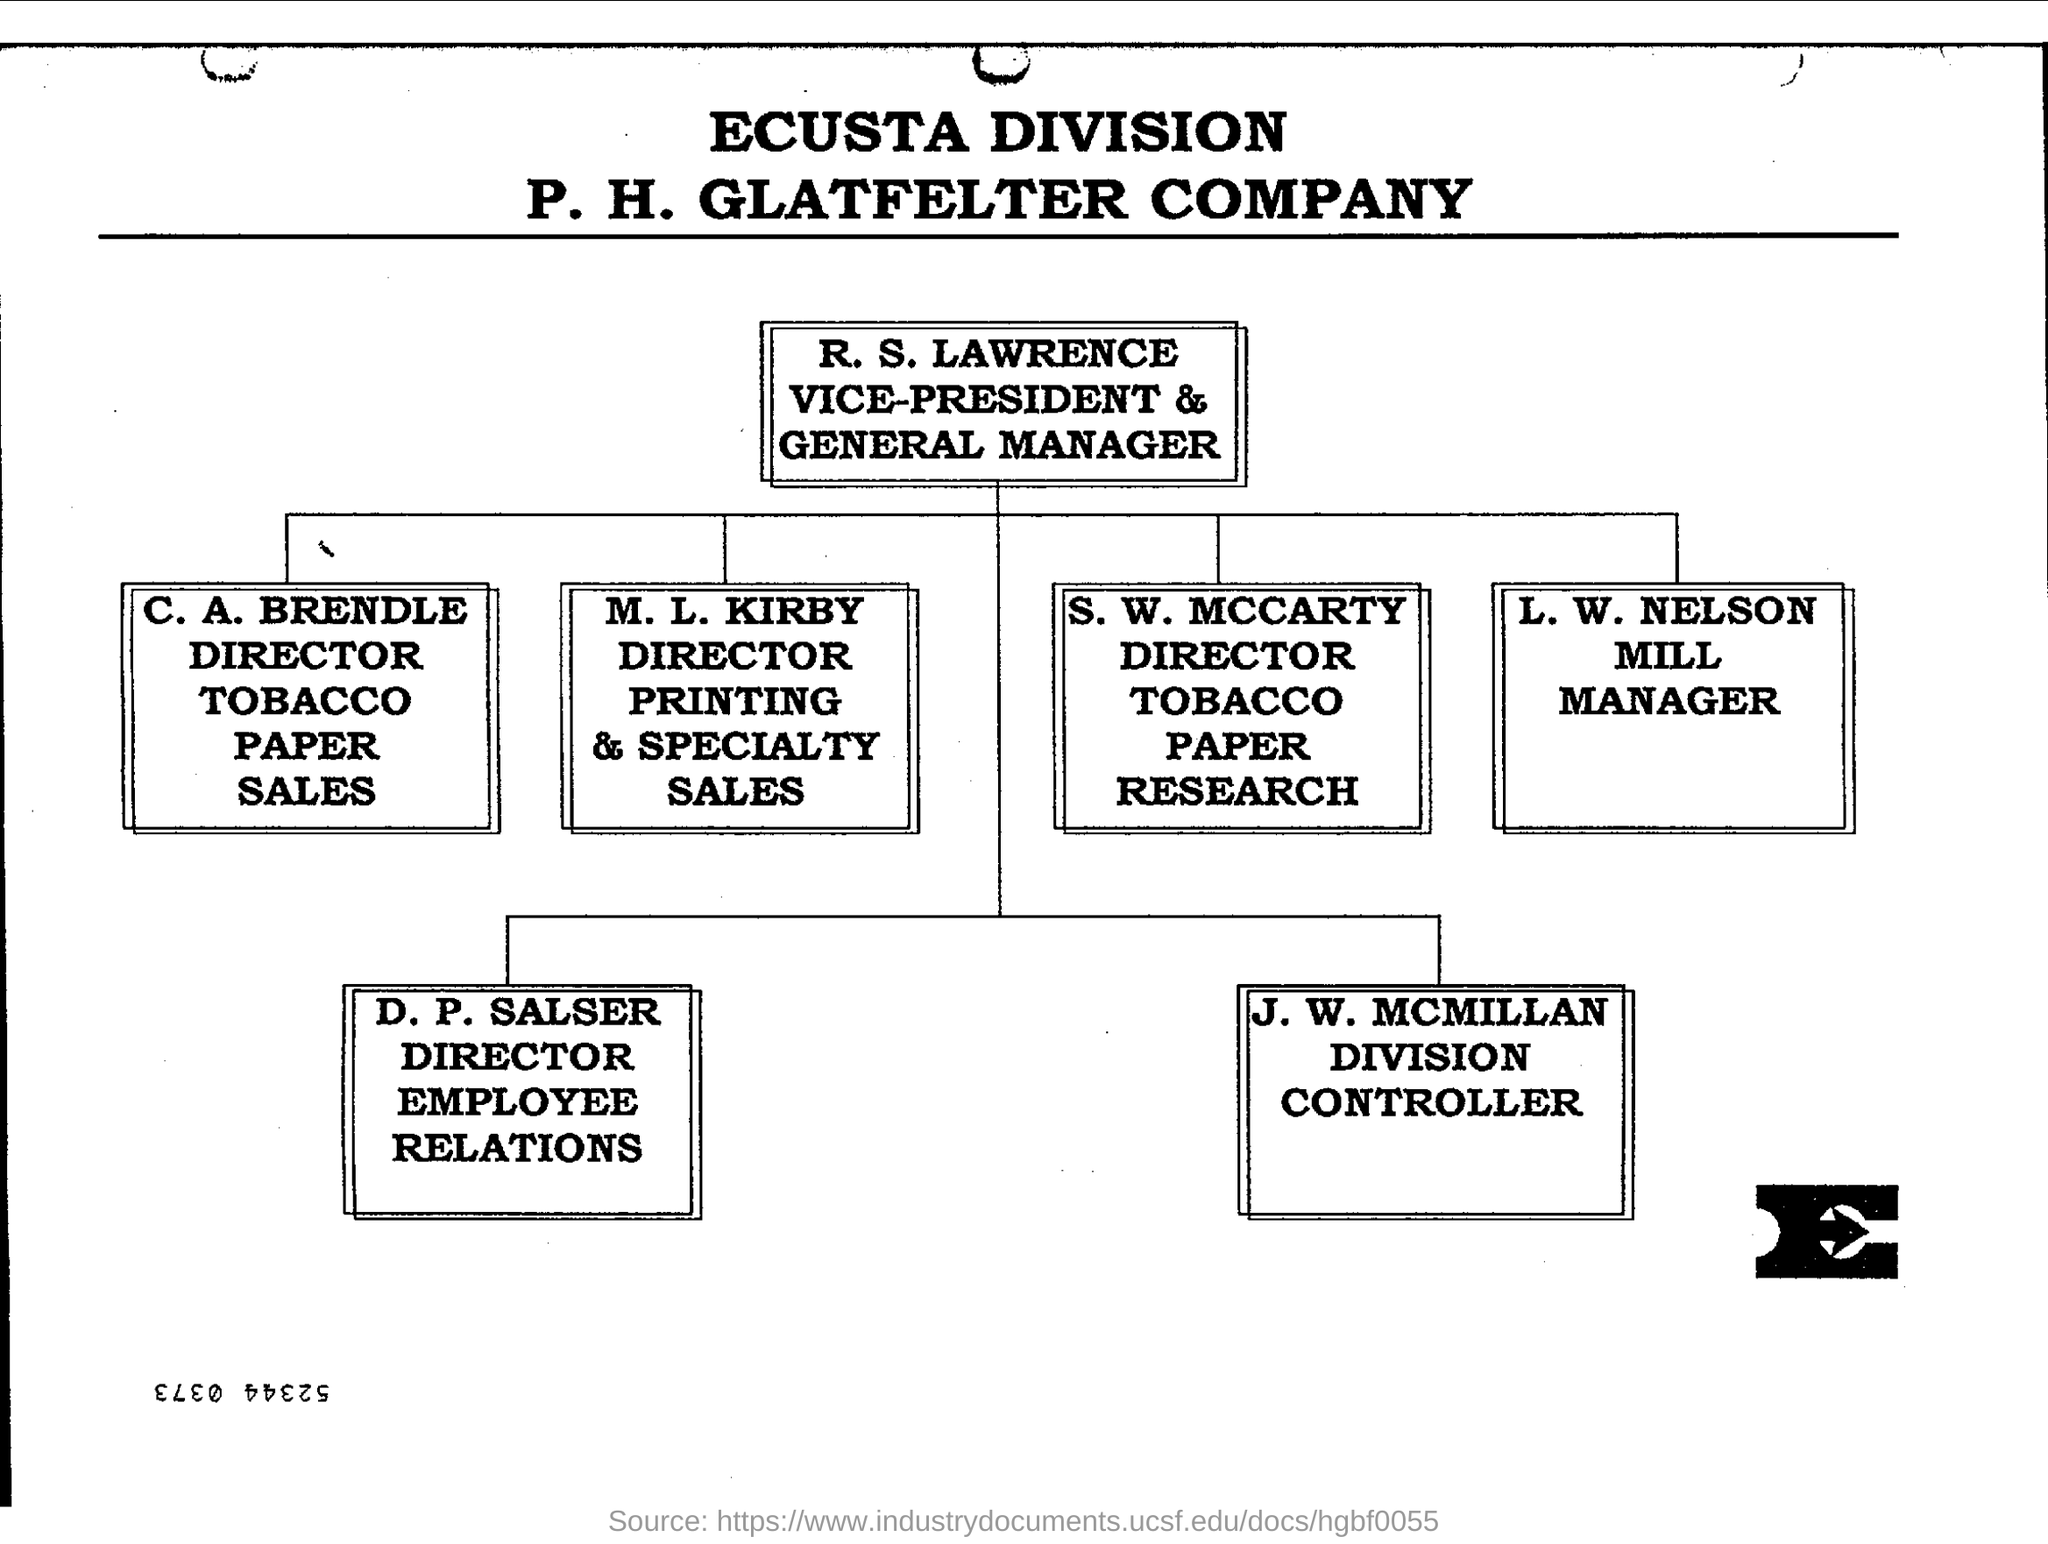What is the Company Name in the Document?
Make the answer very short. P. H. GLATFELTER COMPANY. Who is the Mill Manager?
Provide a short and direct response. L. W. Nelson. 